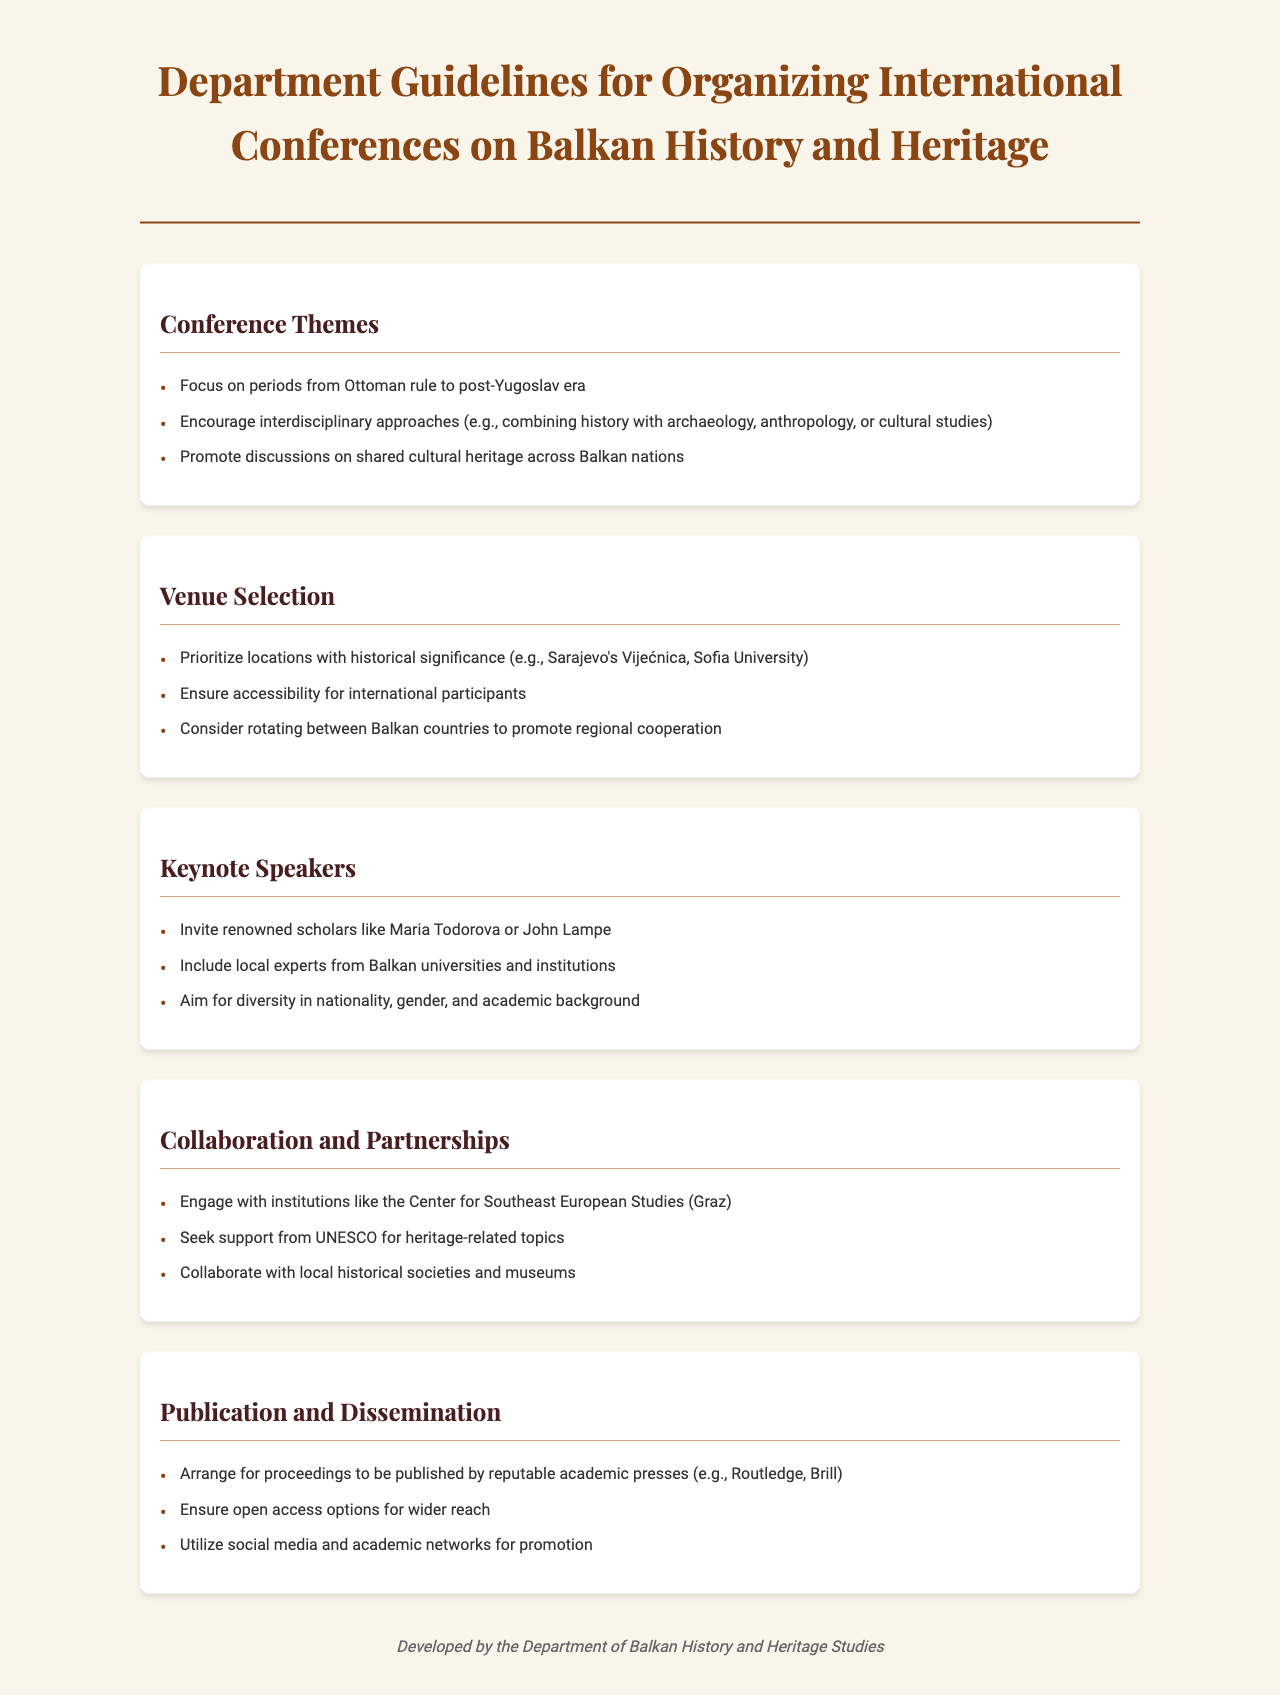What are the focal periods for the conference themes? The document specifies that the focal periods include the Ottoman rule to the post-Yugoslav era.
Answer: Ottoman rule to post-Yugoslav era Who is mentioned as a keynote speaker? The document lists Maria Todorova and John Lampe as renowned scholars to be invited as keynote speakers.
Answer: Maria Todorova or John Lampe What type of venues should be prioritized? The guidelines suggest prioritizing venues with historical significance.
Answer: Historical significance Which organization is recommended for collaboration in heritage-related topics? The document states that support should be sought from UNESCO for heritage-related topics.
Answer: UNESCO What should be arranged for proceedings publication? The guidelines recommend arranging for proceedings to be published by reputable academic presses.
Answer: Reputable academic presses 